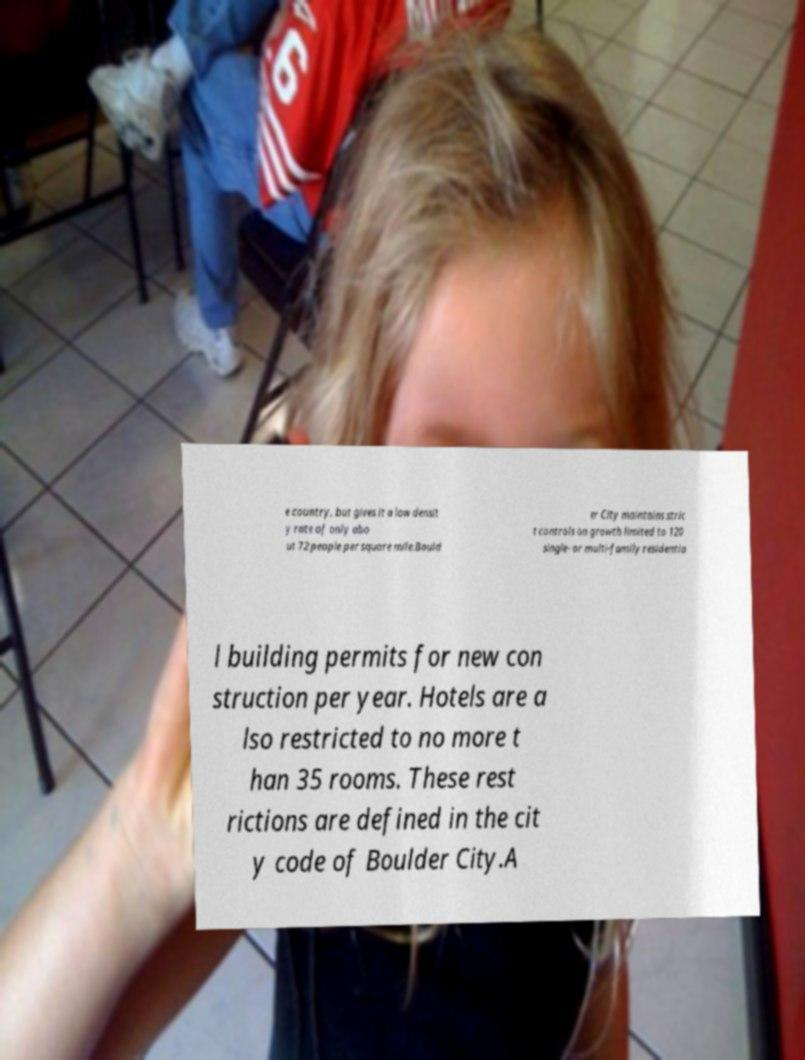What messages or text are displayed in this image? I need them in a readable, typed format. e country, but gives it a low densit y rate of only abo ut 72 people per square mile.Bould er City maintains stric t controls on growth limited to 120 single- or multi-family residentia l building permits for new con struction per year. Hotels are a lso restricted to no more t han 35 rooms. These rest rictions are defined in the cit y code of Boulder City.A 